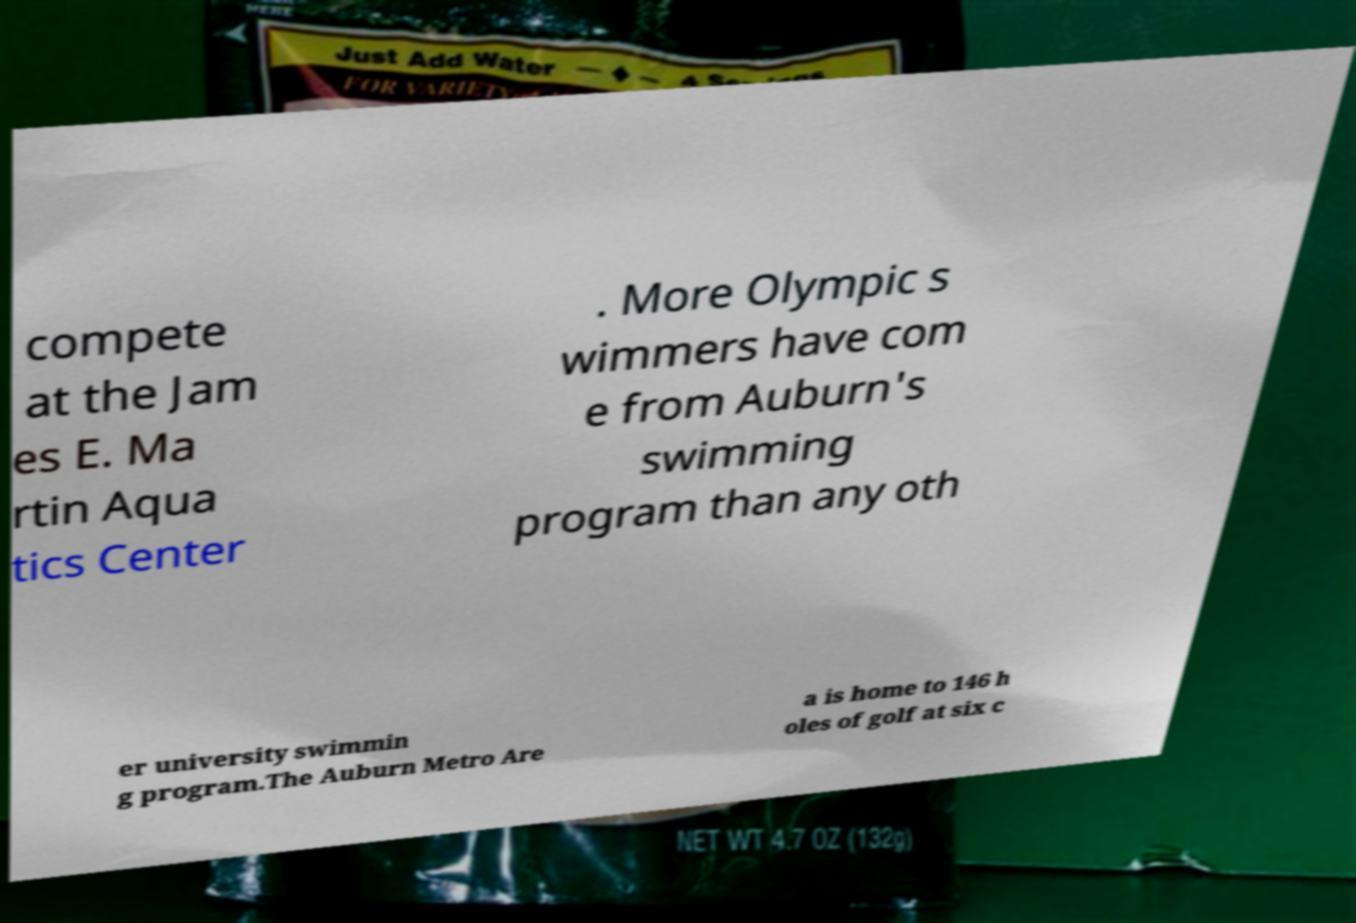For documentation purposes, I need the text within this image transcribed. Could you provide that? compete at the Jam es E. Ma rtin Aqua tics Center . More Olympic s wimmers have com e from Auburn's swimming program than any oth er university swimmin g program.The Auburn Metro Are a is home to 146 h oles of golf at six c 